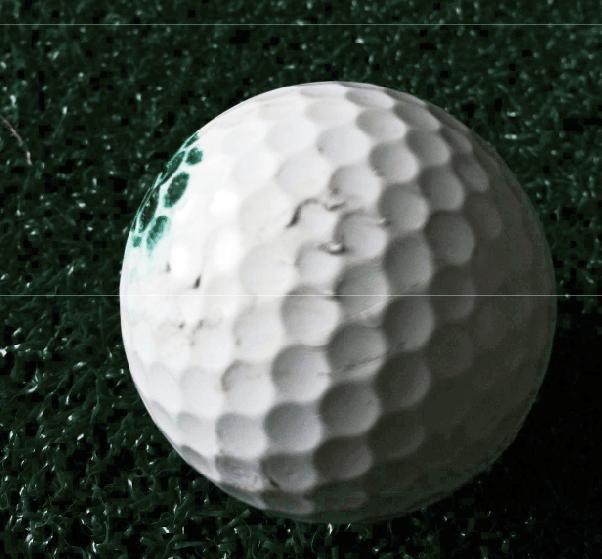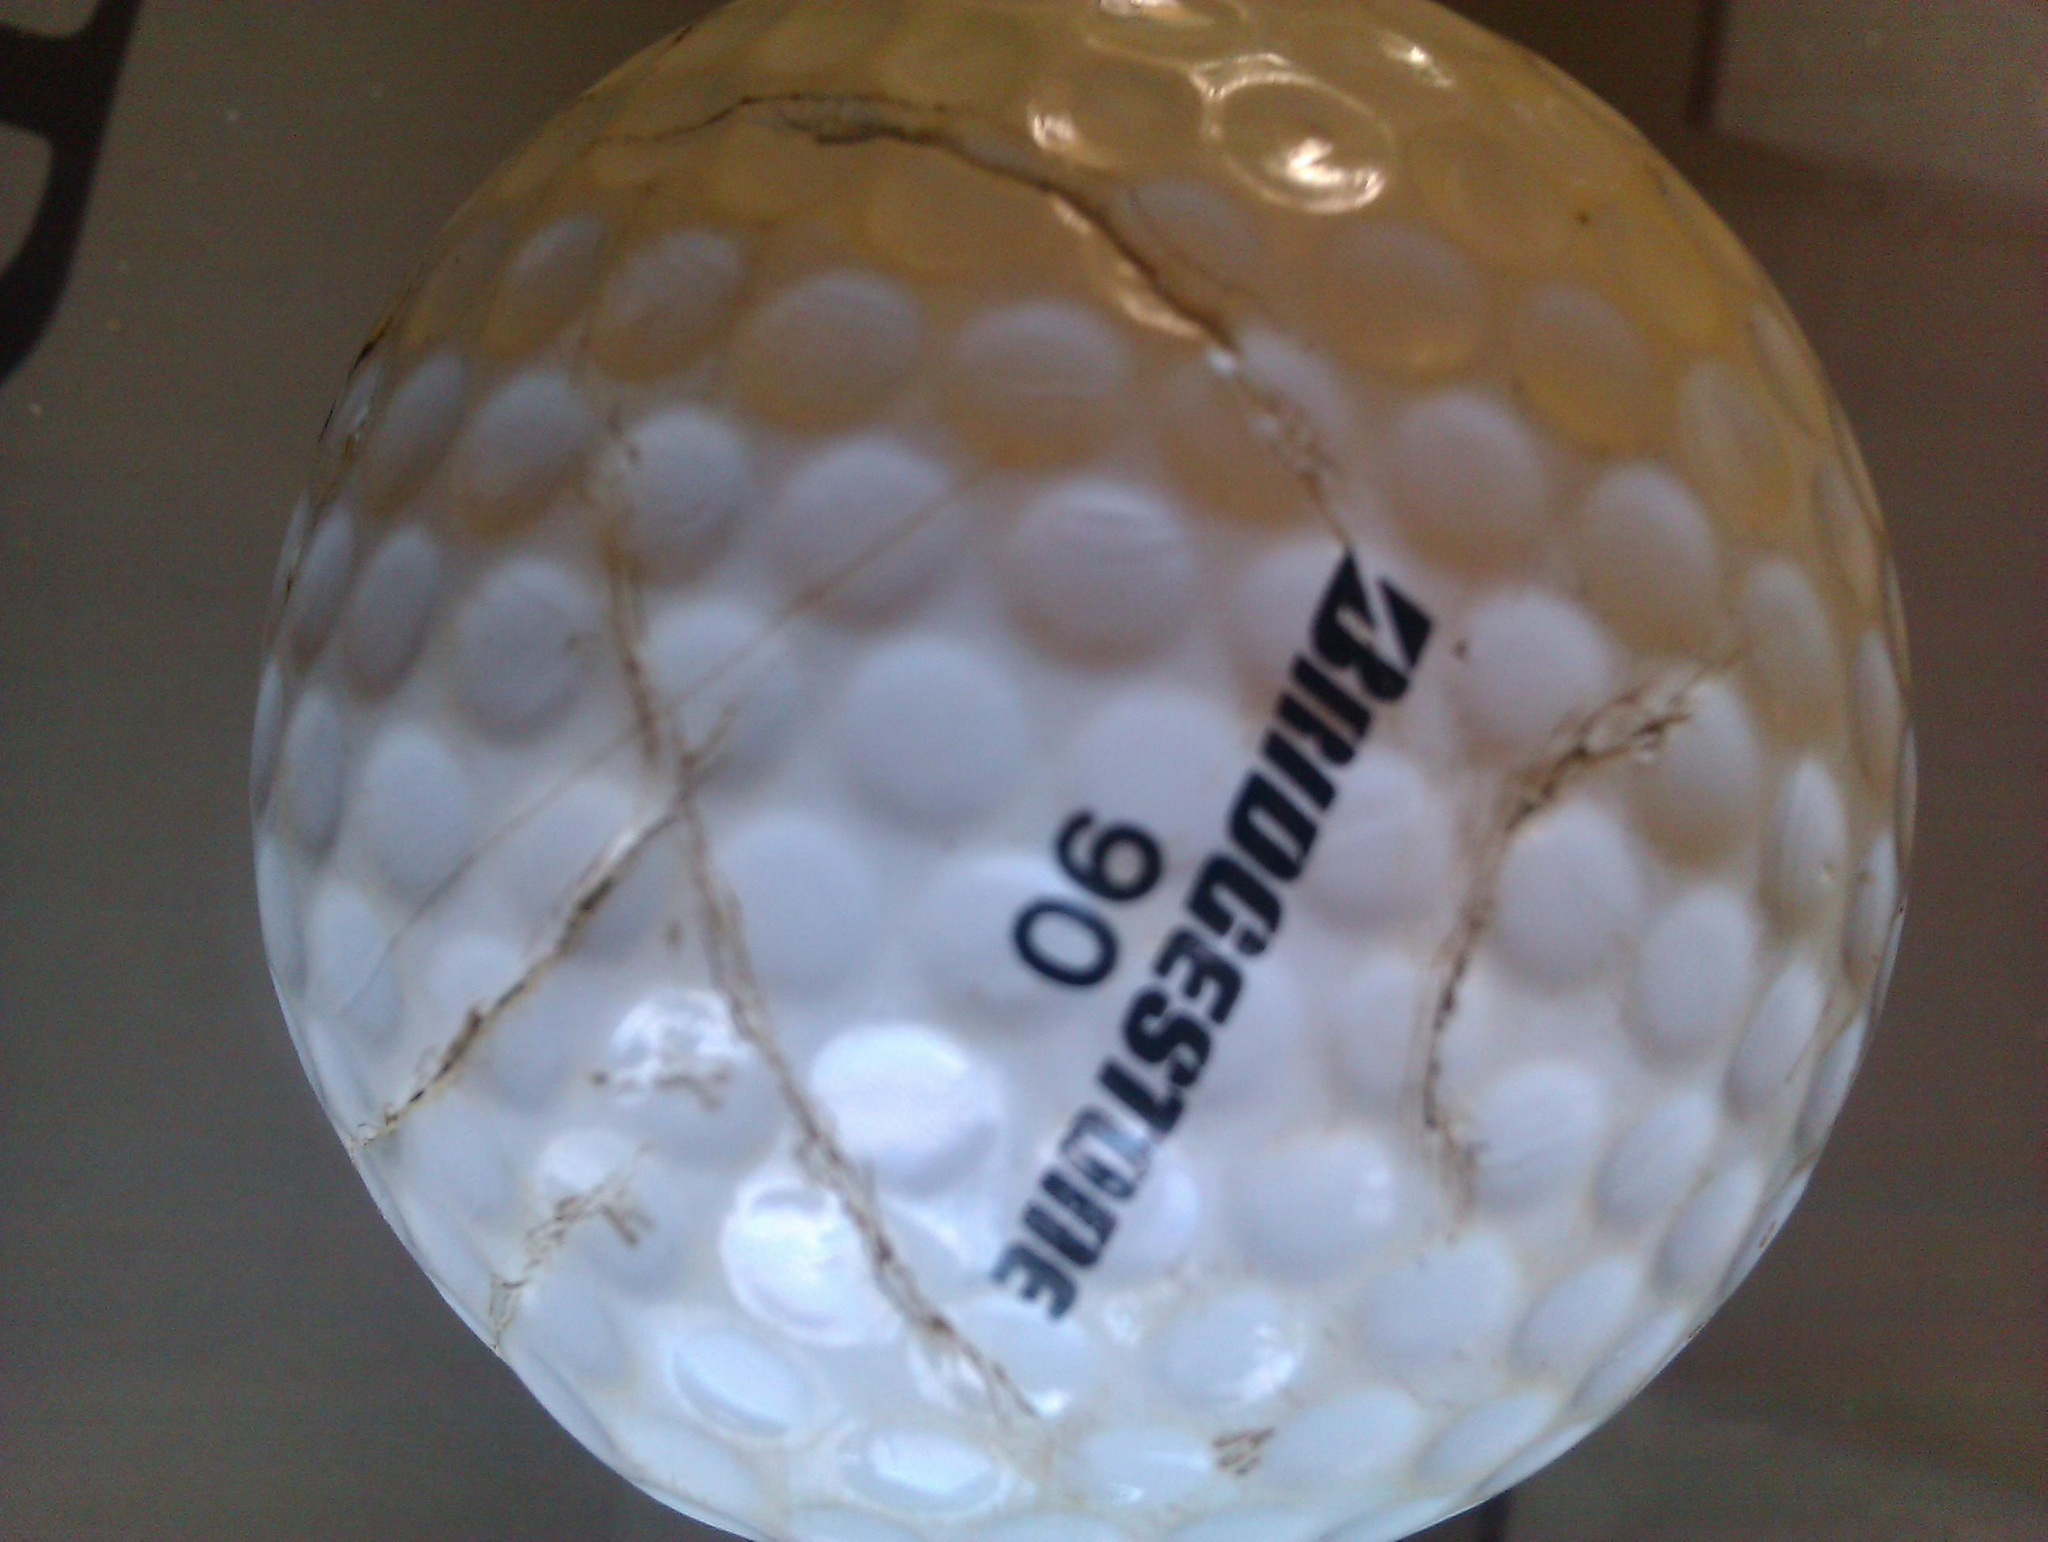The first image is the image on the left, the second image is the image on the right. For the images shown, is this caption "The left and right image contains the same number of golf balls with at least one in a person's hand." true? Answer yes or no. No. The first image is the image on the left, the second image is the image on the right. Evaluate the accuracy of this statement regarding the images: "Part of a hand is touching one real golf ball in the lefthand image.". Is it true? Answer yes or no. No. 